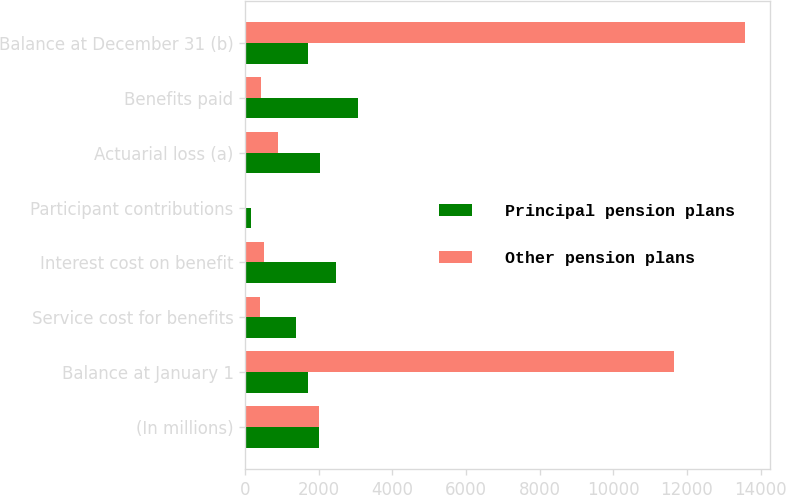<chart> <loc_0><loc_0><loc_500><loc_500><stacked_bar_chart><ecel><fcel>(In millions)<fcel>Balance at January 1<fcel>Service cost for benefits<fcel>Interest cost on benefit<fcel>Participant contributions<fcel>Actuarial loss (a)<fcel>Benefits paid<fcel>Balance at December 31 (b)<nl><fcel>Principal pension plans<fcel>2012<fcel>1699.5<fcel>1387<fcel>2479<fcel>157<fcel>2021<fcel>3052<fcel>1699.5<nl><fcel>Other pension plans<fcel>2012<fcel>11637<fcel>392<fcel>514<fcel>16<fcel>890<fcel>425<fcel>13584<nl></chart> 